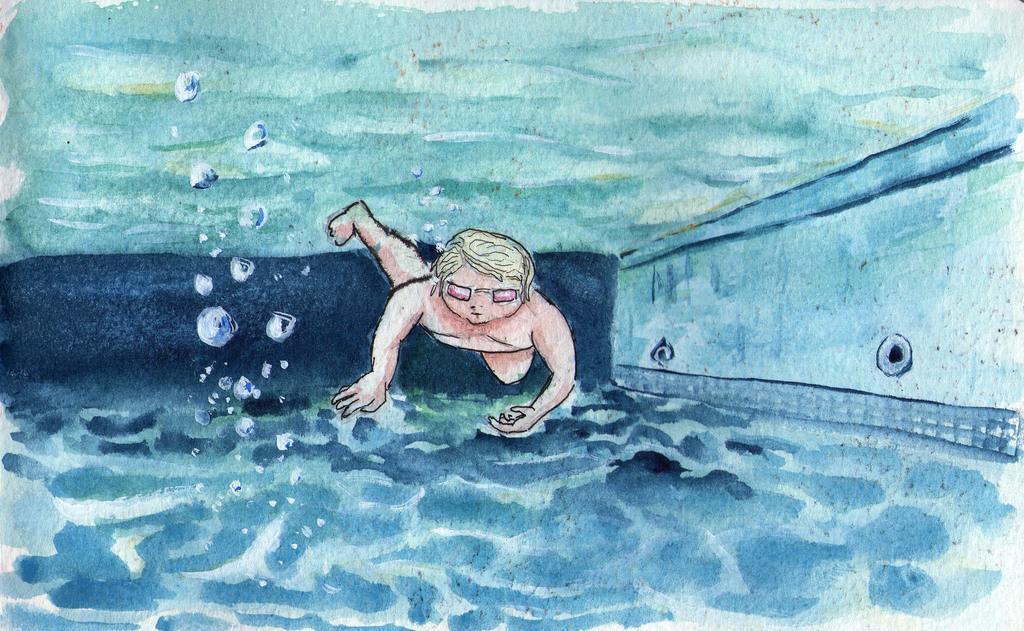In one or two sentences, can you explain what this image depicts? In this image there is a painting, in that there is a person swimming in the pool. 